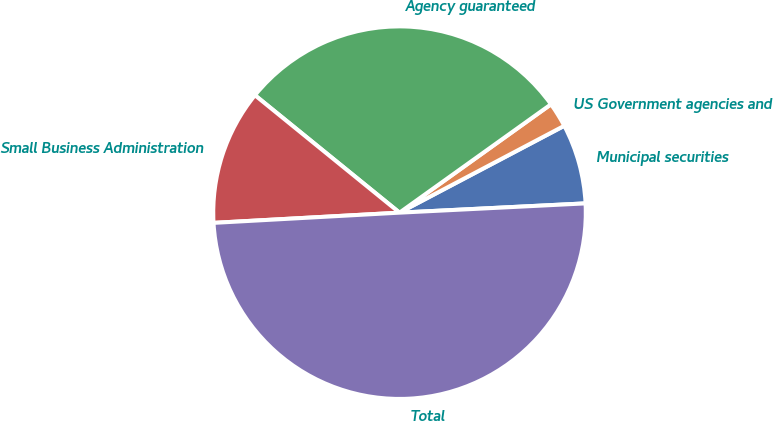Convert chart. <chart><loc_0><loc_0><loc_500><loc_500><pie_chart><fcel>Municipal securities<fcel>US Government agencies and<fcel>Agency guaranteed<fcel>Small Business Administration<fcel>Total<nl><fcel>6.93%<fcel>2.16%<fcel>29.26%<fcel>11.73%<fcel>49.92%<nl></chart> 